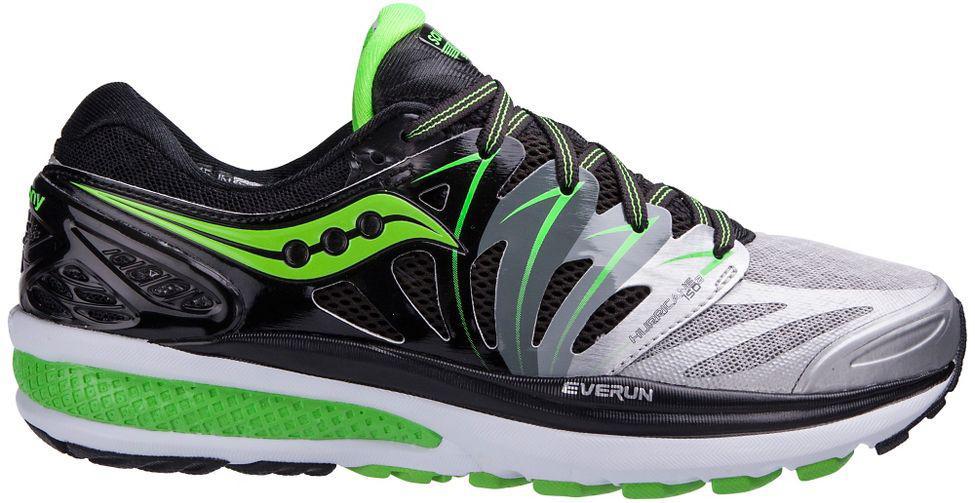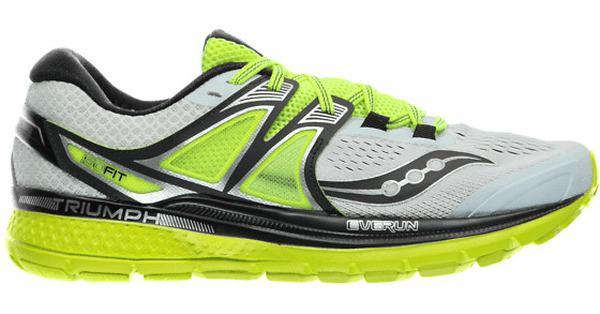The first image is the image on the left, the second image is the image on the right. Considering the images on both sides, is "Each image contains one right-facing shoe with bright colored treads on the bottom of the sole." valid? Answer yes or no. Yes. The first image is the image on the left, the second image is the image on the right. Given the left and right images, does the statement "Both shoes are pointing to the right." hold true? Answer yes or no. Yes. 